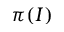<formula> <loc_0><loc_0><loc_500><loc_500>\pi ( I )</formula> 